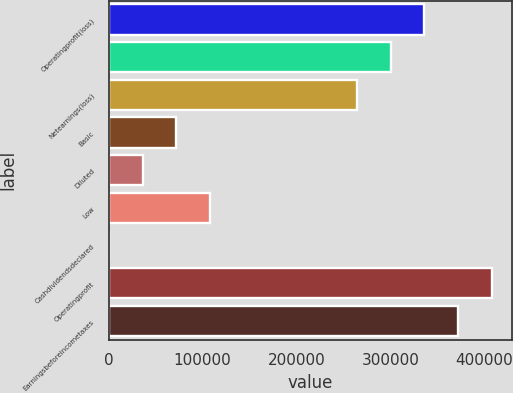<chart> <loc_0><loc_0><loc_500><loc_500><bar_chart><fcel>Operatingprofit(loss)<fcel>Unnamed: 1<fcel>Netearnings(loss)<fcel>Basic<fcel>Diluted<fcel>Low<fcel>Cashdividendsdeclared<fcel>Operatingprofit<fcel>Earningsbeforeincometaxes<nl><fcel>336050<fcel>299955<fcel>263861<fcel>72189.3<fcel>36095<fcel>108284<fcel>0.63<fcel>408238<fcel>372144<nl></chart> 